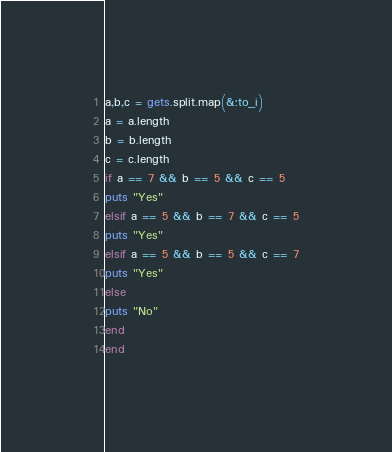Convert code to text. <code><loc_0><loc_0><loc_500><loc_500><_Ruby_>a,b,c = gets.split.map(&:to_i)
a = a.length
b = b.length
c = c.length
if a == 7 && b == 5 && c == 5
puts "Yes"
elsif a == 5 && b == 7 && c == 5
puts "Yes"
elsif a == 5 && b == 5 && c == 7
puts "Yes"
else
puts "No"
end
end
</code> 